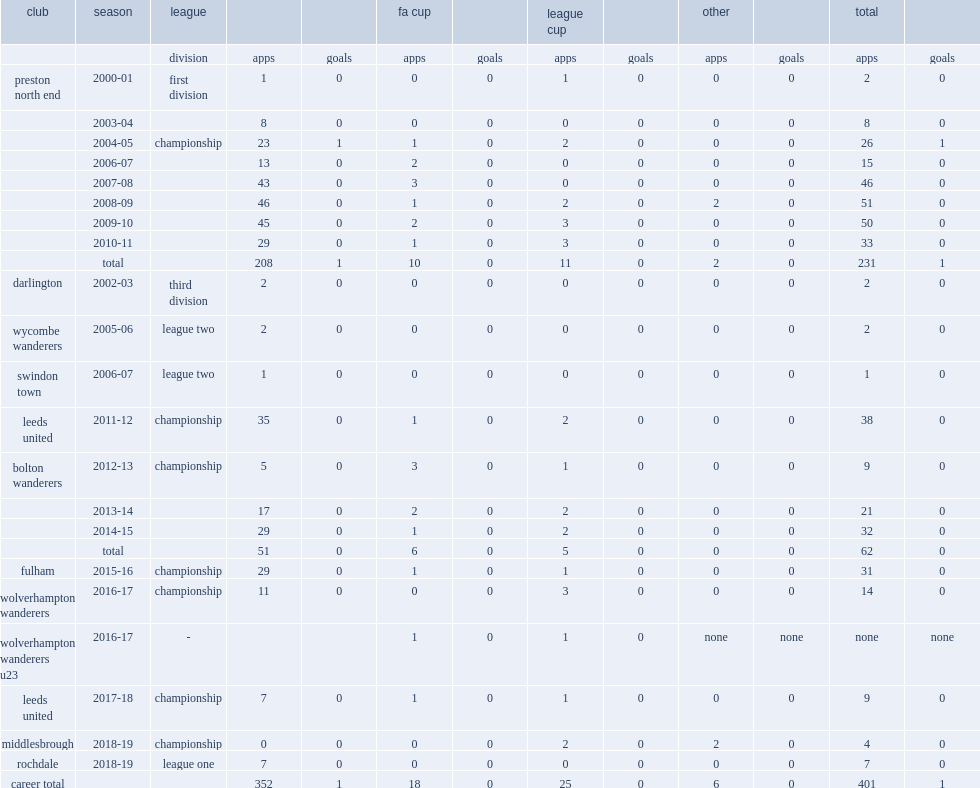Could you parse the entire table? {'header': ['club', 'season', 'league', '', '', 'fa cup', '', 'league cup', '', 'other', '', 'total', ''], 'rows': [['', '', 'division', 'apps', 'goals', 'apps', 'goals', 'apps', 'goals', 'apps', 'goals', 'apps', 'goals'], ['preston north end', '2000-01', 'first division', '1', '0', '0', '0', '1', '0', '0', '0', '2', '0'], ['', '2003-04', '', '8', '0', '0', '0', '0', '0', '0', '0', '8', '0'], ['', '2004-05', 'championship', '23', '1', '1', '0', '2', '0', '0', '0', '26', '1'], ['', '2006-07', '', '13', '0', '2', '0', '0', '0', '0', '0', '15', '0'], ['', '2007-08', '', '43', '0', '3', '0', '0', '0', '0', '0', '46', '0'], ['', '2008-09', '', '46', '0', '1', '0', '2', '0', '2', '0', '51', '0'], ['', '2009-10', '', '45', '0', '2', '0', '3', '0', '0', '0', '50', '0'], ['', '2010-11', '', '29', '0', '1', '0', '3', '0', '0', '0', '33', '0'], ['', 'total', '', '208', '1', '10', '0', '11', '0', '2', '0', '231', '1'], ['darlington', '2002-03', 'third division', '2', '0', '0', '0', '0', '0', '0', '0', '2', '0'], ['wycombe wanderers', '2005-06', 'league two', '2', '0', '0', '0', '0', '0', '0', '0', '2', '0'], ['swindon town', '2006-07', 'league two', '1', '0', '0', '0', '0', '0', '0', '0', '1', '0'], ['leeds united', '2011-12', 'championship', '35', '0', '1', '0', '2', '0', '0', '0', '38', '0'], ['bolton wanderers', '2012-13', 'championship', '5', '0', '3', '0', '1', '0', '0', '0', '9', '0'], ['', '2013-14', '', '17', '0', '2', '0', '2', '0', '0', '0', '21', '0'], ['', '2014-15', '', '29', '0', '1', '0', '2', '0', '0', '0', '32', '0'], ['', 'total', '', '51', '0', '6', '0', '5', '0', '0', '0', '62', '0'], ['fulham', '2015-16', 'championship', '29', '0', '1', '0', '1', '0', '0', '0', '31', '0'], ['wolverhampton wanderers', '2016-17', 'championship', '11', '0', '0', '0', '3', '0', '0', '0', '14', '0'], ['wolverhampton wanderers u23', '2016-17', '-', '', '', '1', '0', '1', '0', 'none', 'none', 'none', 'none'], ['leeds united', '2017-18', 'championship', '7', '0', '1', '0', '1', '0', '0', '0', '9', '0'], ['middlesbrough', '2018-19', 'championship', '0', '0', '0', '0', '2', '0', '2', '0', '4', '0'], ['rochdale', '2018-19', 'league one', '7', '0', '0', '0', '0', '0', '0', '0', '7', '0'], ['career total', '', '', '352', '1', '18', '0', '25', '0', '6', '0', '401', '1']]} In total, how many appearances did lonergan make during his career at preston north end? 231.0. 